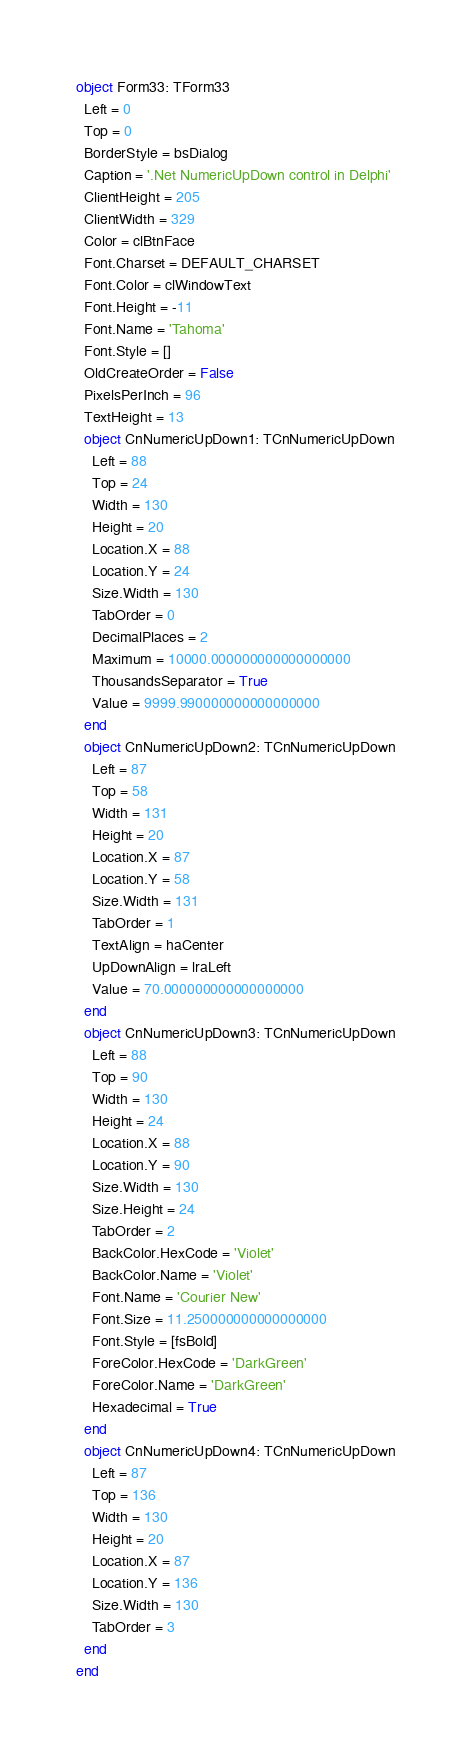Convert code to text. <code><loc_0><loc_0><loc_500><loc_500><_Pascal_>object Form33: TForm33
  Left = 0
  Top = 0
  BorderStyle = bsDialog
  Caption = '.Net NumericUpDown control in Delphi'
  ClientHeight = 205
  ClientWidth = 329
  Color = clBtnFace
  Font.Charset = DEFAULT_CHARSET
  Font.Color = clWindowText
  Font.Height = -11
  Font.Name = 'Tahoma'
  Font.Style = []
  OldCreateOrder = False
  PixelsPerInch = 96
  TextHeight = 13
  object CnNumericUpDown1: TCnNumericUpDown
    Left = 88
    Top = 24
    Width = 130
    Height = 20
    Location.X = 88
    Location.Y = 24
    Size.Width = 130
    TabOrder = 0
    DecimalPlaces = 2
    Maximum = 10000.000000000000000000
    ThousandsSeparator = True
    Value = 9999.990000000000000000
  end
  object CnNumericUpDown2: TCnNumericUpDown
    Left = 87
    Top = 58
    Width = 131
    Height = 20
    Location.X = 87
    Location.Y = 58
    Size.Width = 131
    TabOrder = 1
    TextAlign = haCenter
    UpDownAlign = lraLeft
    Value = 70.000000000000000000
  end
  object CnNumericUpDown3: TCnNumericUpDown
    Left = 88
    Top = 90
    Width = 130
    Height = 24
    Location.X = 88
    Location.Y = 90
    Size.Width = 130
    Size.Height = 24
    TabOrder = 2
    BackColor.HexCode = 'Violet'
    BackColor.Name = 'Violet'
    Font.Name = 'Courier New'
    Font.Size = 11.250000000000000000
    Font.Style = [fsBold]
    ForeColor.HexCode = 'DarkGreen'
    ForeColor.Name = 'DarkGreen'
    Hexadecimal = True
  end
  object CnNumericUpDown4: TCnNumericUpDown
    Left = 87
    Top = 136
    Width = 130
    Height = 20
    Location.X = 87
    Location.Y = 136
    Size.Width = 130
    TabOrder = 3
  end
end
</code> 